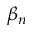<formula> <loc_0><loc_0><loc_500><loc_500>\beta _ { n }</formula> 